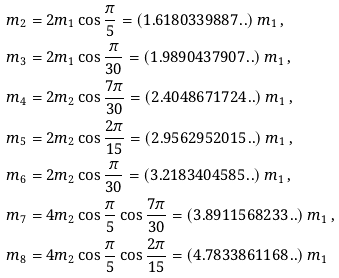Convert formula to latex. <formula><loc_0><loc_0><loc_500><loc_500>m _ { 2 } & = 2 m _ { 1 } \cos \frac { \pi } { 5 } = ( 1 . 6 1 8 0 3 3 9 8 8 7 . . ) \, m _ { 1 } \, , \\ m _ { 3 } & = 2 m _ { 1 } \cos \frac { \pi } { 3 0 } = ( 1 . 9 8 9 0 4 3 7 9 0 7 . . ) \, m _ { 1 } \, , \\ m _ { 4 } & = 2 m _ { 2 } \cos \frac { 7 \pi } { 3 0 } = ( 2 . 4 0 4 8 6 7 1 7 2 4 . . ) \, m _ { 1 } \, , \\ m _ { 5 } & = 2 m _ { 2 } \cos \frac { 2 \pi } { 1 5 } = ( 2 . 9 5 6 2 9 5 2 0 1 5 . . ) \, m _ { 1 } \, , \\ m _ { 6 } & = 2 m _ { 2 } \cos \frac { \pi } { 3 0 } = ( 3 . 2 1 8 3 4 0 4 5 8 5 . . ) \, m _ { 1 } \, , \\ m _ { 7 } & = 4 m _ { 2 } \cos \frac { \pi } { 5 } \cos \frac { 7 \pi } { 3 0 } = ( 3 . 8 9 1 1 5 6 8 2 3 3 . . ) \, m _ { 1 } \, , \\ m _ { 8 } & = 4 m _ { 2 } \cos \frac { \pi } { 5 } \cos \frac { 2 \pi } { 1 5 } = ( 4 . 7 8 3 3 8 6 1 1 6 8 . . ) \, m _ { 1 } \,</formula> 